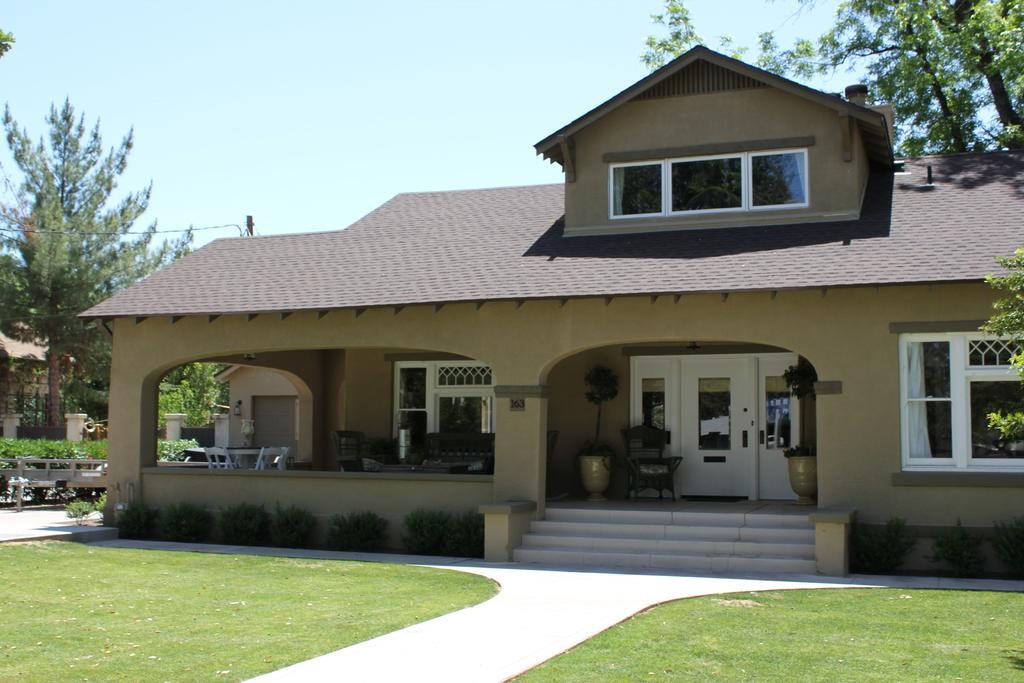How would you summarize this image in a sentence or two? In this image I can see there are buildings. And there are flower pot, table and chairs. And in front there is a grass. And at the side there is a bench on the ground. And at the back there are trees and a pole. And at the top there is a sky. 